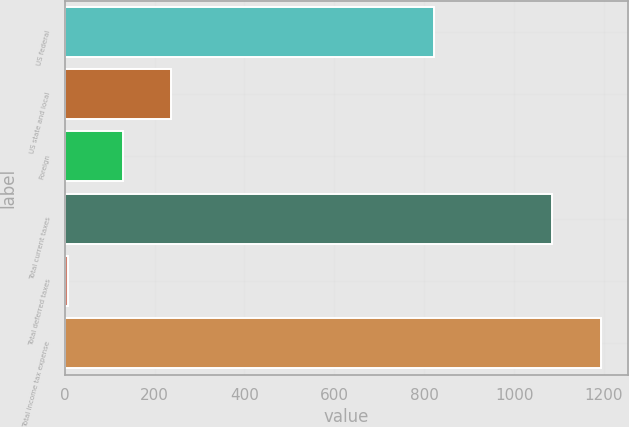Convert chart to OTSL. <chart><loc_0><loc_0><loc_500><loc_500><bar_chart><fcel>US federal<fcel>US state and local<fcel>Foreign<fcel>Total current taxes<fcel>Total deferred taxes<fcel>Total income tax expense<nl><fcel>822.7<fcel>237.24<fcel>128.8<fcel>1084.4<fcel>7.6<fcel>1192.84<nl></chart> 